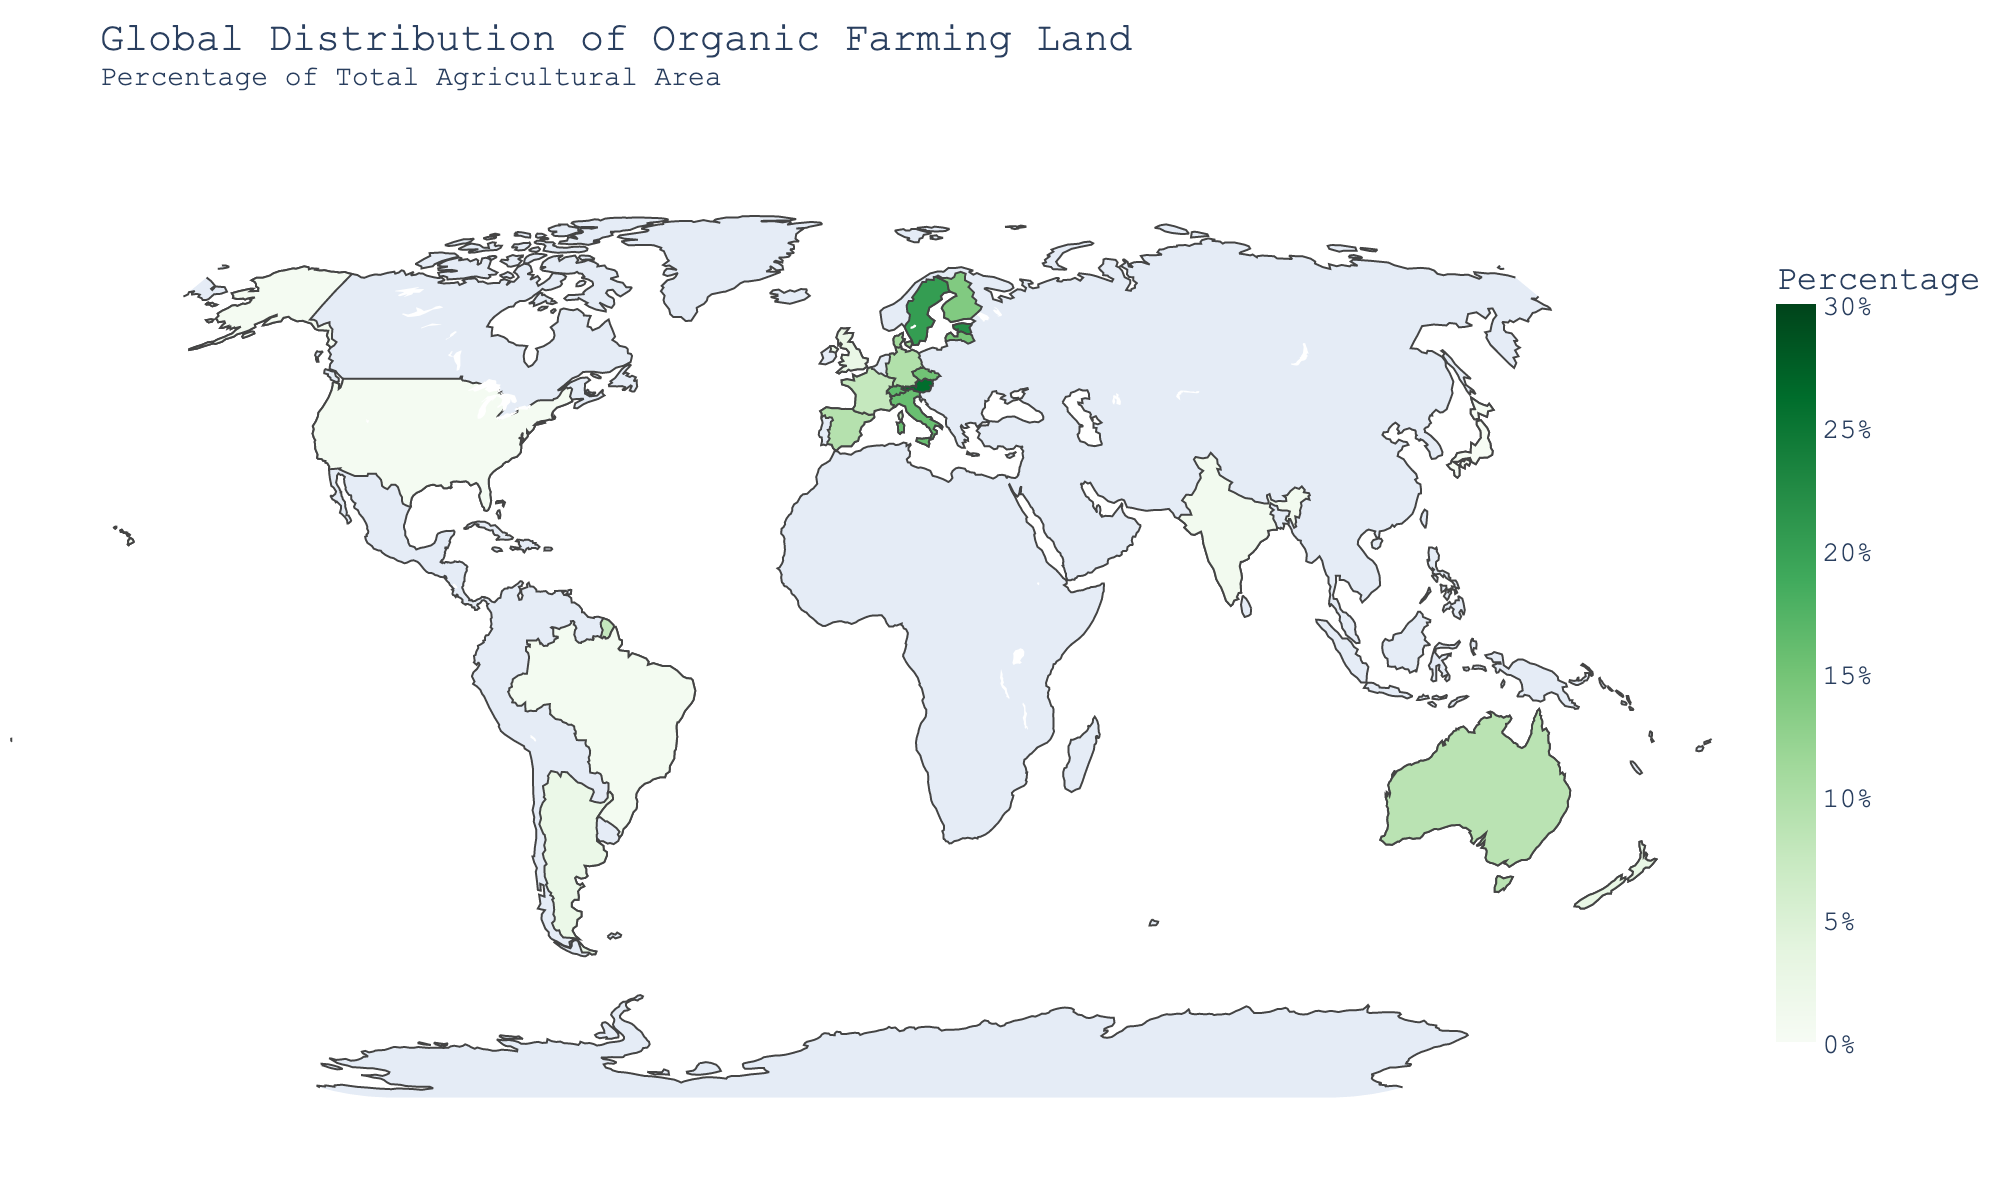What's the title of the figure? The title is given at the top of the figure.
Answer: Global Distribution of Organic Farming Land - Percentage of Total Agricultural Area Which country has the highest percentage of organic farming land? The country with the darkest green color represents the highest percentage.
Answer: Austria What percentage of agricultural land in Sweden is dedicated to organic farming? Hovering over Sweden will show its organic farming percentage.
Answer: 20.4% How does Germany's organic farming percentage compare to Australia's? From the color and hover information, Germany is slightly below Australia's percentage, which can also be confirmed by the hover tooltip showing Germany's percentage as 9.7% and Australia's as 8.8%.
Answer: Germany has a higher percentage than Australia Which countries have an organic farming land percentage higher than 20%? Identify the countries with darker shades of green above the threshold of 20% and confirm with the hover tooltip.
Answer: Austria, Estonia, and Sweden How does the organic farming percentage in France compare to that in Spain? By comparing the hover tooltips for France (7.7%) and Spain (9.3%), Spain has a higher percentage.
Answer: Spain has a higher percentage than France What is the percentage difference in organic farming land between the United States and the United Kingdom? Subtract the percentage of the United States (0.6%) from that of the United Kingdom (2.7%).
Answer: 2.1% Which country in the data has the lowest organic farming percentage? Look for the country with the lightest shade of green, and confirm using the hover tooltip.
Answer: Japan What is the average percentage of organic farming land for the countries listed? Sum all the percentages and divide by the number of countries: (26.1 + 22.3 + 20.4 + 15.8 + 14.8 + 16.5 + 13.9 + 15.2 + 11.1 + 9.7 + 9.3 + 7.7 + 2.7 + 0.6 + 8.8 + 2.9 + 1.1 + 2.4 + 0.8 + 0.2) / 20.
Answer: 9.2% How does organic farming distribution vary across continents? Observe the spectrum of colors across different continents to understand the variance in organic farming percentages visually. European countries show darker greens indicating higher percentages compared to countries in Asia, North America, and South America.
Answer: Higher in Europe, lower in Asia and the Americas 